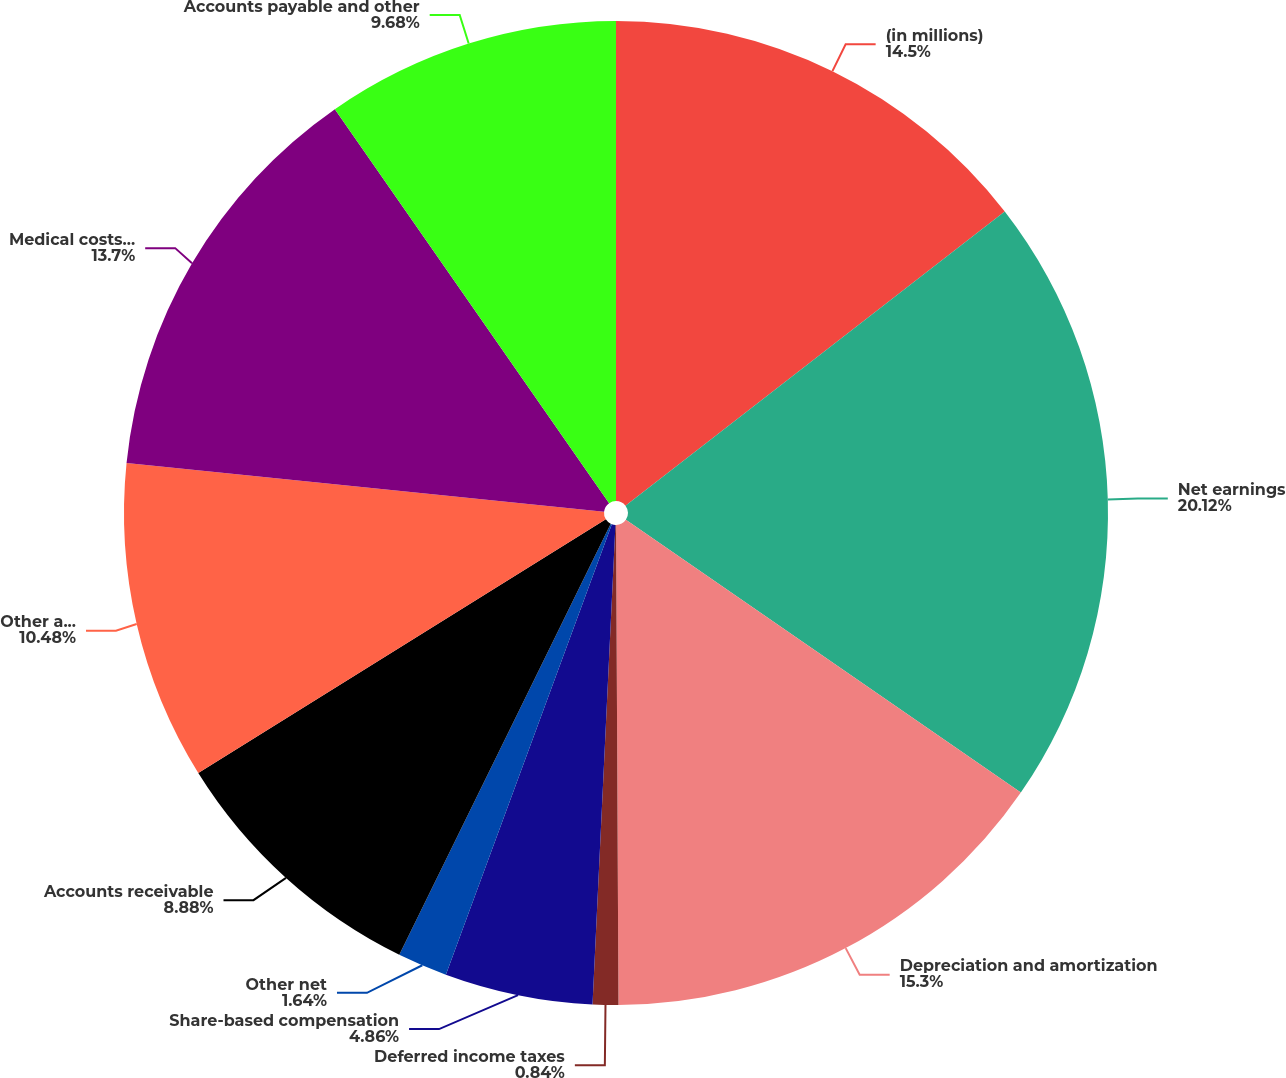<chart> <loc_0><loc_0><loc_500><loc_500><pie_chart><fcel>(in millions)<fcel>Net earnings<fcel>Depreciation and amortization<fcel>Deferred income taxes<fcel>Share-based compensation<fcel>Other net<fcel>Accounts receivable<fcel>Other assets<fcel>Medical costs payable<fcel>Accounts payable and other<nl><fcel>14.5%<fcel>20.12%<fcel>15.3%<fcel>0.84%<fcel>4.86%<fcel>1.64%<fcel>8.88%<fcel>10.48%<fcel>13.7%<fcel>9.68%<nl></chart> 